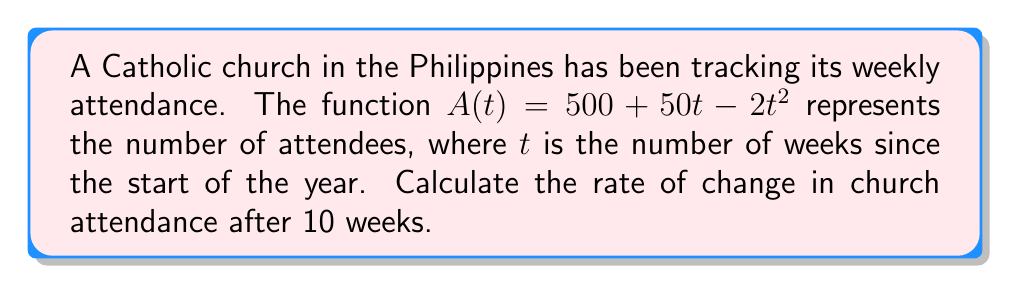Help me with this question. To find the rate of change in church attendance after 10 weeks, we need to calculate the derivative of $A(t)$ and evaluate it at $t=10$.

1. Given function: $A(t) = 500 + 50t - 2t^2$

2. Calculate the derivative $A'(t)$:
   $A'(t) = \frac{d}{dt}(500 + 50t - 2t^2)$
   $A'(t) = 0 + 50 - 4t$
   $A'(t) = 50 - 4t$

3. Evaluate $A'(t)$ at $t=10$:
   $A'(10) = 50 - 4(10)$
   $A'(10) = 50 - 40$
   $A'(10) = 10$

The rate of change after 10 weeks is 10 attendees per week.

Note: The negative sign indicates that the attendance is decreasing at this point.
Answer: $-10$ attendees/week 